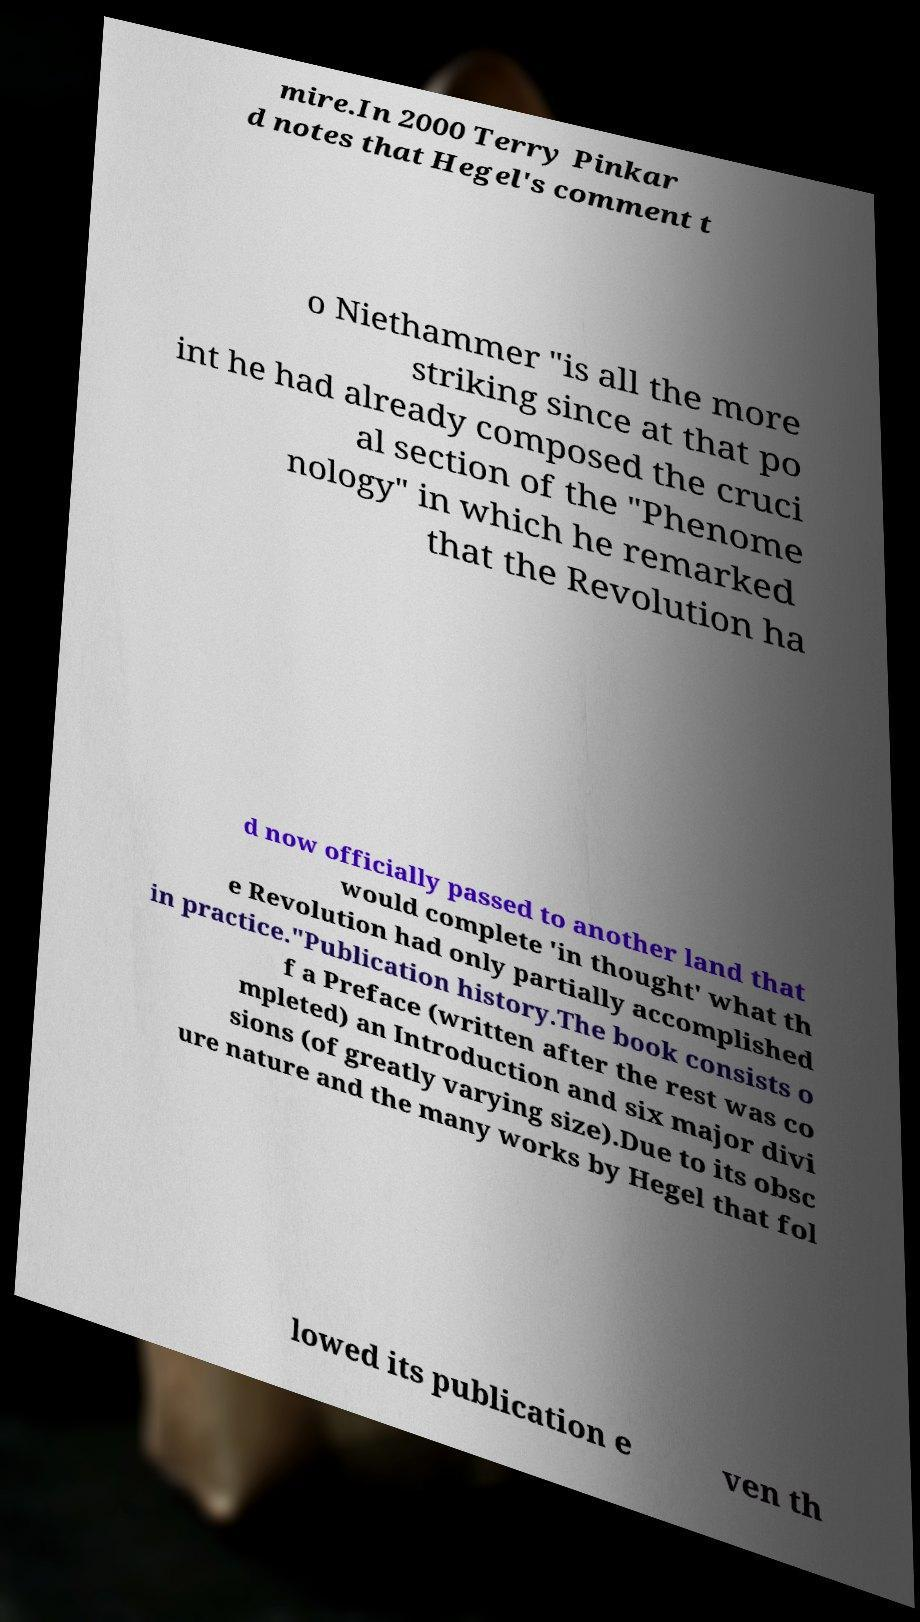There's text embedded in this image that I need extracted. Can you transcribe it verbatim? mire.In 2000 Terry Pinkar d notes that Hegel's comment t o Niethammer "is all the more striking since at that po int he had already composed the cruci al section of the "Phenome nology" in which he remarked that the Revolution ha d now officially passed to another land that would complete 'in thought' what th e Revolution had only partially accomplished in practice."Publication history.The book consists o f a Preface (written after the rest was co mpleted) an Introduction and six major divi sions (of greatly varying size).Due to its obsc ure nature and the many works by Hegel that fol lowed its publication e ven th 